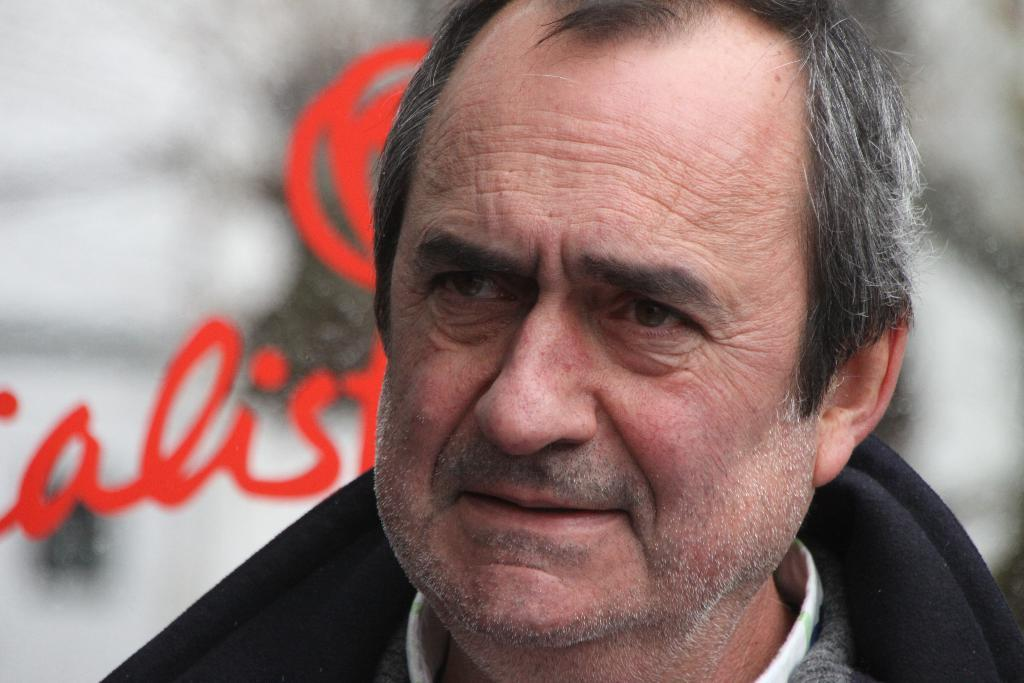What is present in the image? There is a man in the image. Can you describe what the man is wearing? The man is wearing a black coat. What else can be seen in the image? There is text visible in the background of the image. Where is the man's aunt in the image? There is no mention of an aunt in the image, so it cannot be determined where she might be. What type of crown is the man wearing in the image? There is no crown visible in the image; the man is wearing a black coat. Can you see a bear in the image? There is no bear present in the image. 